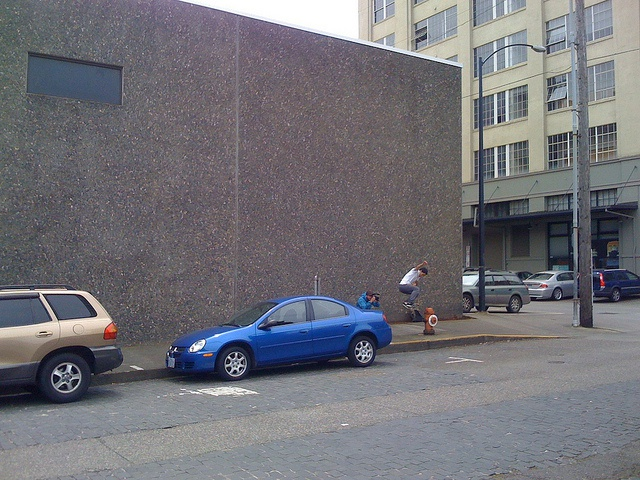Describe the objects in this image and their specific colors. I can see car in gray, navy, black, and lightblue tones, car in gray, black, lightgray, and darkgray tones, car in gray, black, darkgray, and white tones, car in gray, darkgray, and black tones, and car in gray, navy, black, and blue tones in this image. 